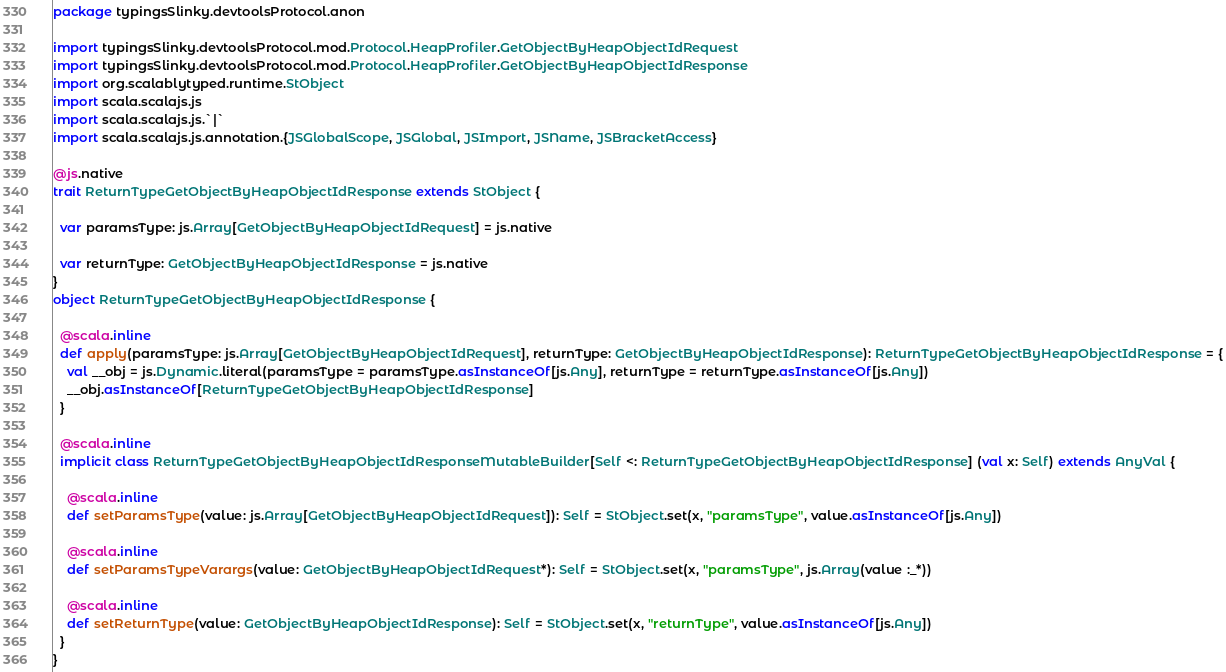<code> <loc_0><loc_0><loc_500><loc_500><_Scala_>package typingsSlinky.devtoolsProtocol.anon

import typingsSlinky.devtoolsProtocol.mod.Protocol.HeapProfiler.GetObjectByHeapObjectIdRequest
import typingsSlinky.devtoolsProtocol.mod.Protocol.HeapProfiler.GetObjectByHeapObjectIdResponse
import org.scalablytyped.runtime.StObject
import scala.scalajs.js
import scala.scalajs.js.`|`
import scala.scalajs.js.annotation.{JSGlobalScope, JSGlobal, JSImport, JSName, JSBracketAccess}

@js.native
trait ReturnTypeGetObjectByHeapObjectIdResponse extends StObject {
  
  var paramsType: js.Array[GetObjectByHeapObjectIdRequest] = js.native
  
  var returnType: GetObjectByHeapObjectIdResponse = js.native
}
object ReturnTypeGetObjectByHeapObjectIdResponse {
  
  @scala.inline
  def apply(paramsType: js.Array[GetObjectByHeapObjectIdRequest], returnType: GetObjectByHeapObjectIdResponse): ReturnTypeGetObjectByHeapObjectIdResponse = {
    val __obj = js.Dynamic.literal(paramsType = paramsType.asInstanceOf[js.Any], returnType = returnType.asInstanceOf[js.Any])
    __obj.asInstanceOf[ReturnTypeGetObjectByHeapObjectIdResponse]
  }
  
  @scala.inline
  implicit class ReturnTypeGetObjectByHeapObjectIdResponseMutableBuilder[Self <: ReturnTypeGetObjectByHeapObjectIdResponse] (val x: Self) extends AnyVal {
    
    @scala.inline
    def setParamsType(value: js.Array[GetObjectByHeapObjectIdRequest]): Self = StObject.set(x, "paramsType", value.asInstanceOf[js.Any])
    
    @scala.inline
    def setParamsTypeVarargs(value: GetObjectByHeapObjectIdRequest*): Self = StObject.set(x, "paramsType", js.Array(value :_*))
    
    @scala.inline
    def setReturnType(value: GetObjectByHeapObjectIdResponse): Self = StObject.set(x, "returnType", value.asInstanceOf[js.Any])
  }
}
</code> 